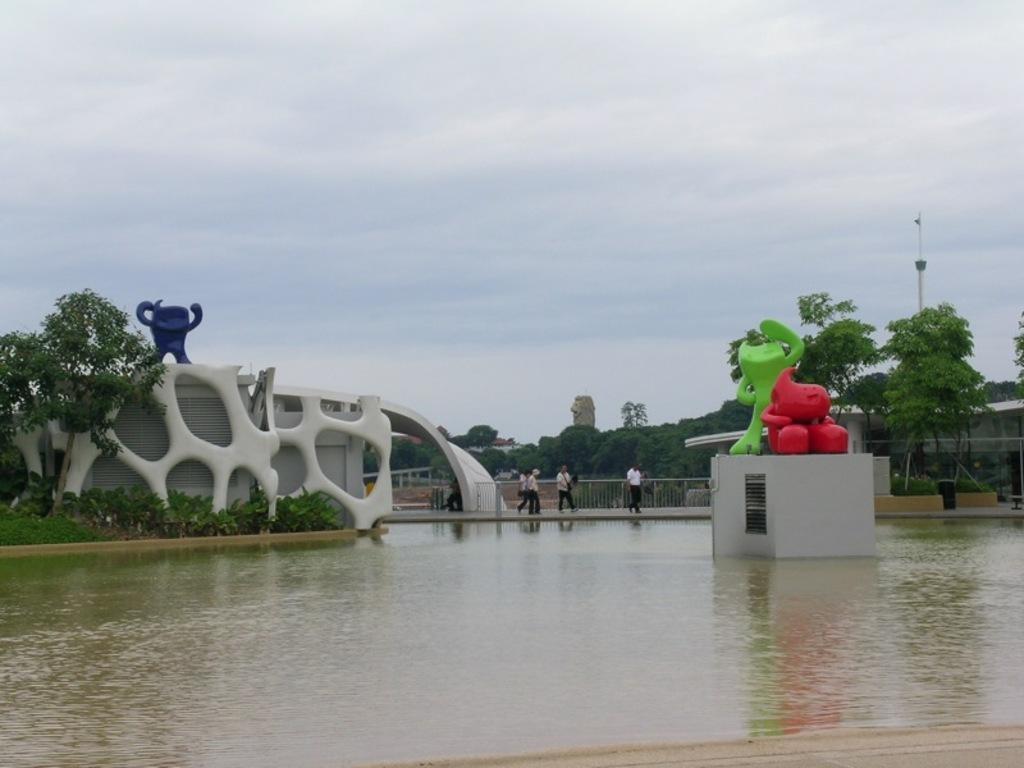Please provide a concise description of this image. In this picture we can see statues, water, trees, fences, buildings, pole and a group of people walking on a path and in the background we can see the sky with clouds. 